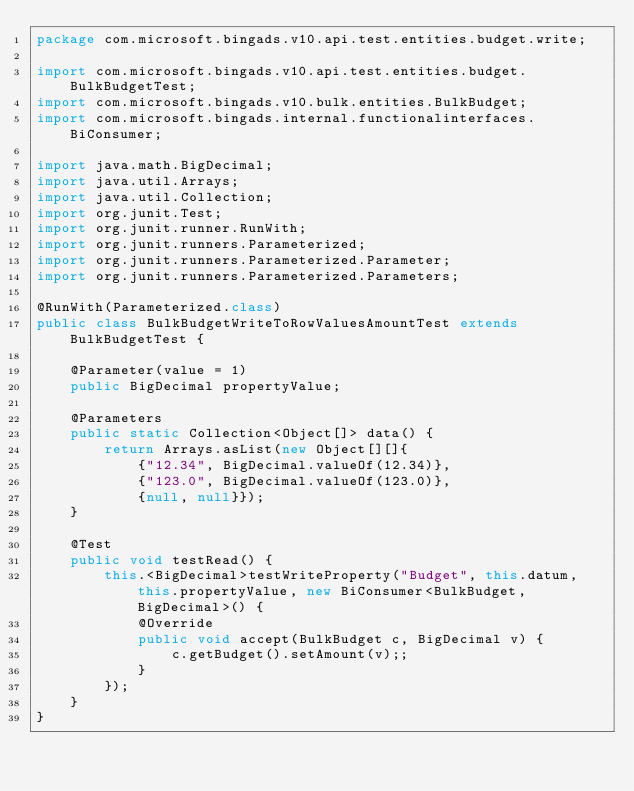Convert code to text. <code><loc_0><loc_0><loc_500><loc_500><_Java_>package com.microsoft.bingads.v10.api.test.entities.budget.write;

import com.microsoft.bingads.v10.api.test.entities.budget.BulkBudgetTest;
import com.microsoft.bingads.v10.bulk.entities.BulkBudget;
import com.microsoft.bingads.internal.functionalinterfaces.BiConsumer;

import java.math.BigDecimal;
import java.util.Arrays;
import java.util.Collection;
import org.junit.Test;
import org.junit.runner.RunWith;
import org.junit.runners.Parameterized;
import org.junit.runners.Parameterized.Parameter;
import org.junit.runners.Parameterized.Parameters;

@RunWith(Parameterized.class)
public class BulkBudgetWriteToRowValuesAmountTest extends BulkBudgetTest {

    @Parameter(value = 1)
    public BigDecimal propertyValue;

    @Parameters
    public static Collection<Object[]> data() {
        return Arrays.asList(new Object[][]{
            {"12.34", BigDecimal.valueOf(12.34)},
            {"123.0", BigDecimal.valueOf(123.0)},
            {null, null}});
    }

    @Test
    public void testRead() {
        this.<BigDecimal>testWriteProperty("Budget", this.datum, this.propertyValue, new BiConsumer<BulkBudget, BigDecimal>() {
            @Override
            public void accept(BulkBudget c, BigDecimal v) {
                c.getBudget().setAmount(v);;
            }
        });
    }
}
</code> 